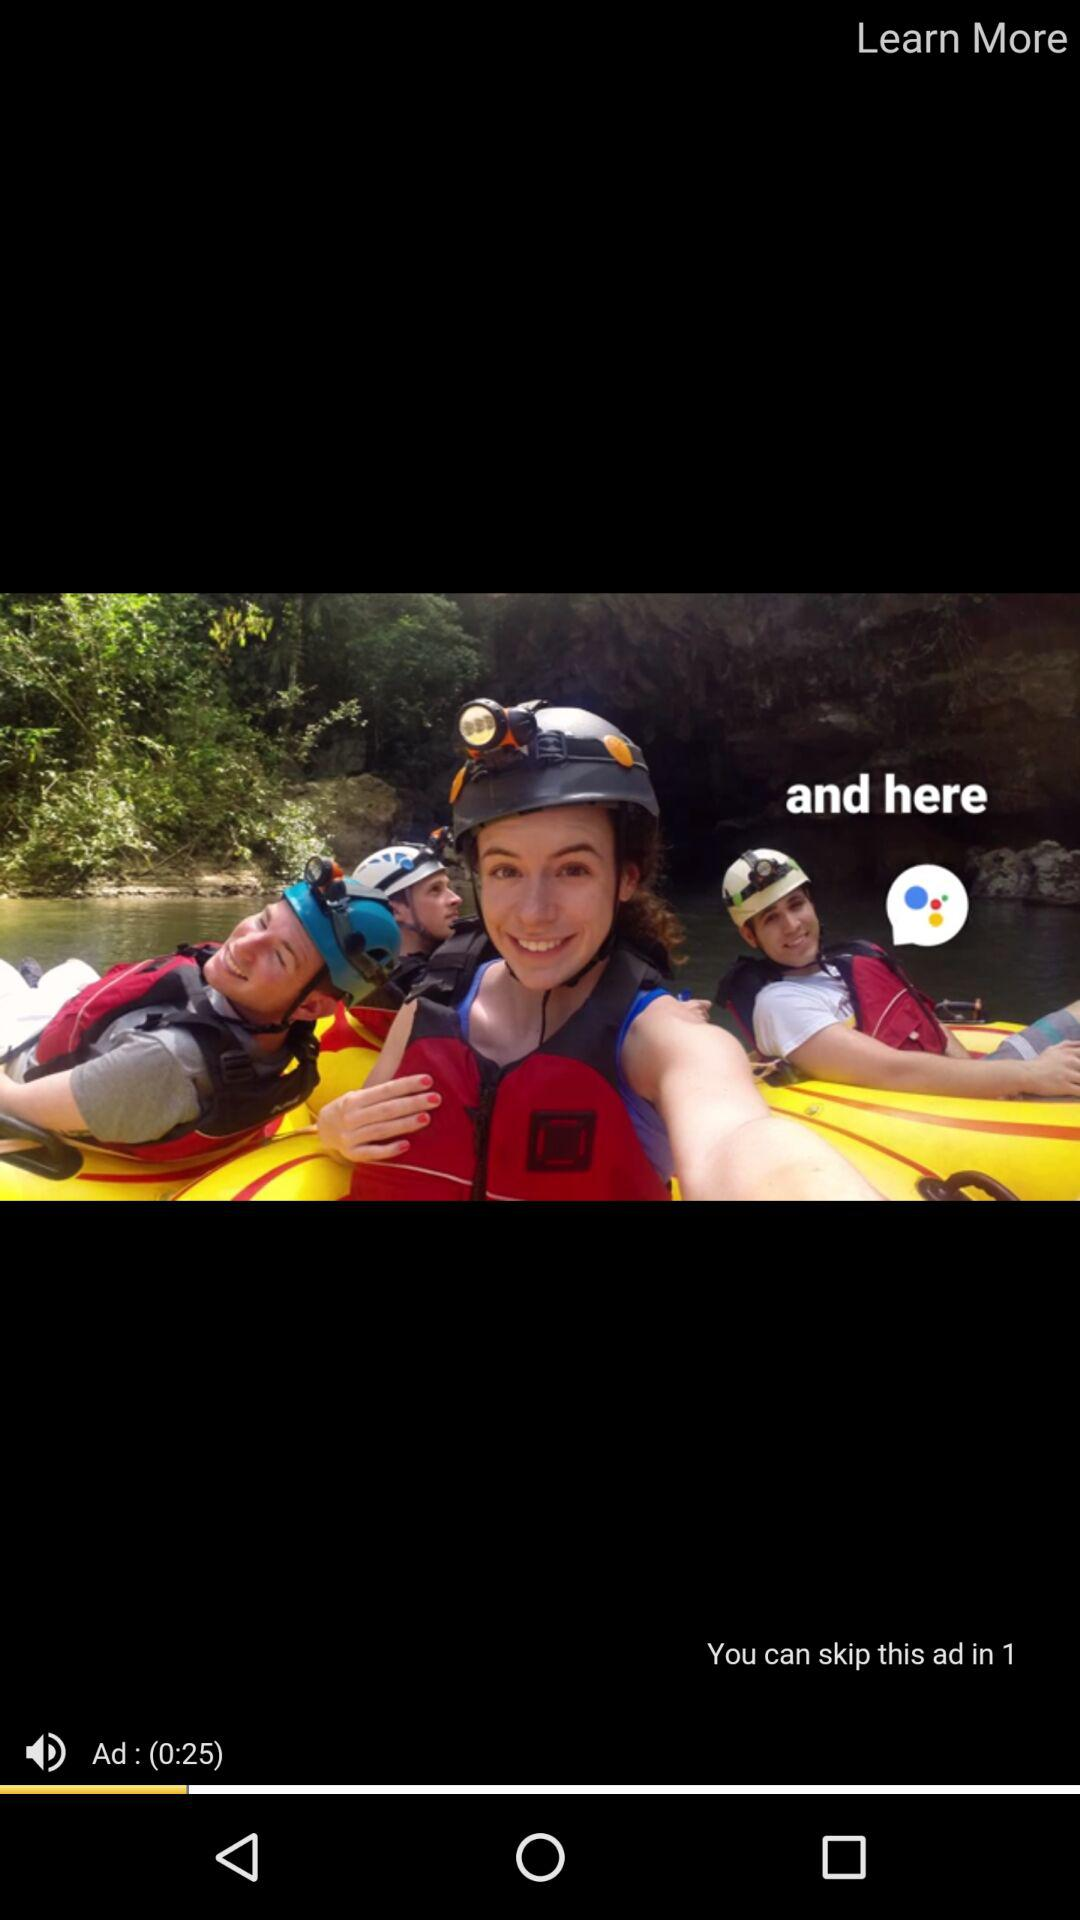How many seconds long is the ad?
Answer the question using a single word or phrase. 25 